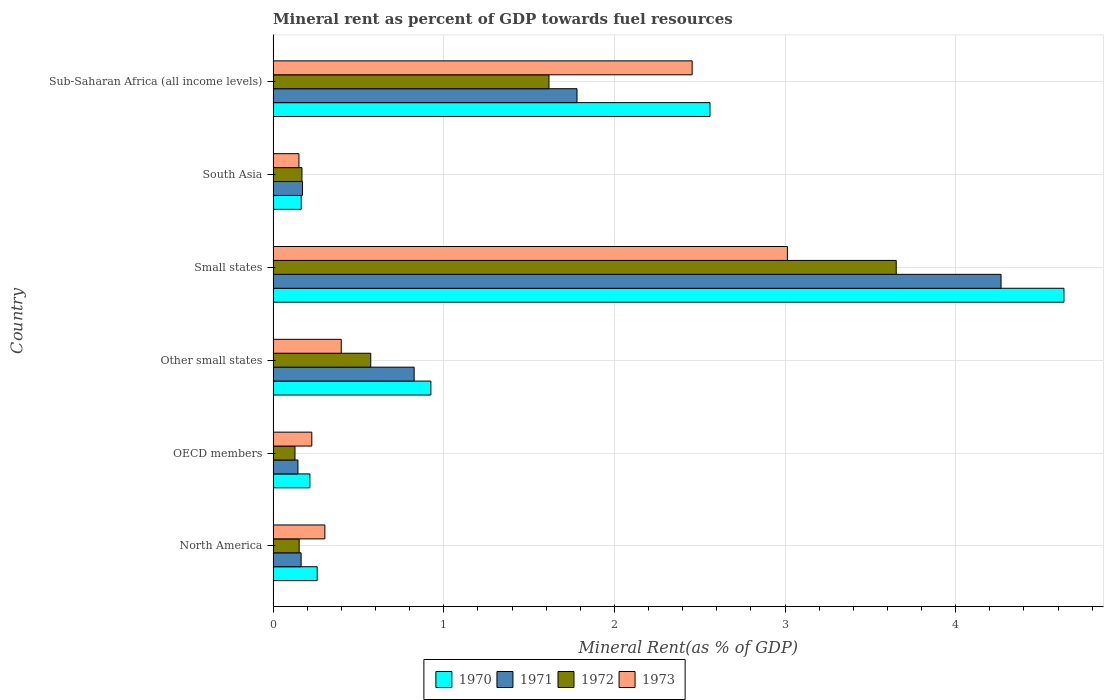Are the number of bars per tick equal to the number of legend labels?
Your answer should be very brief. Yes. How many bars are there on the 1st tick from the bottom?
Offer a very short reply. 4. What is the label of the 6th group of bars from the top?
Your response must be concise. North America. In how many cases, is the number of bars for a given country not equal to the number of legend labels?
Keep it short and to the point. 0. What is the mineral rent in 1970 in OECD members?
Provide a succinct answer. 0.22. Across all countries, what is the maximum mineral rent in 1970?
Ensure brevity in your answer.  4.63. Across all countries, what is the minimum mineral rent in 1973?
Make the answer very short. 0.15. In which country was the mineral rent in 1973 maximum?
Make the answer very short. Small states. In which country was the mineral rent in 1970 minimum?
Ensure brevity in your answer.  South Asia. What is the total mineral rent in 1970 in the graph?
Your answer should be very brief. 8.76. What is the difference between the mineral rent in 1971 in OECD members and that in Small states?
Make the answer very short. -4.12. What is the difference between the mineral rent in 1971 in Sub-Saharan Africa (all income levels) and the mineral rent in 1972 in North America?
Make the answer very short. 1.63. What is the average mineral rent in 1971 per country?
Your response must be concise. 1.23. What is the difference between the mineral rent in 1970 and mineral rent in 1972 in Other small states?
Provide a short and direct response. 0.35. In how many countries, is the mineral rent in 1971 greater than 3.8 %?
Offer a very short reply. 1. What is the ratio of the mineral rent in 1972 in Other small states to that in South Asia?
Keep it short and to the point. 3.38. Is the mineral rent in 1970 in OECD members less than that in South Asia?
Ensure brevity in your answer.  No. Is the difference between the mineral rent in 1970 in Small states and South Asia greater than the difference between the mineral rent in 1972 in Small states and South Asia?
Keep it short and to the point. Yes. What is the difference between the highest and the second highest mineral rent in 1970?
Ensure brevity in your answer.  2.07. What is the difference between the highest and the lowest mineral rent in 1970?
Your answer should be very brief. 4.47. Is the sum of the mineral rent in 1971 in Other small states and Small states greater than the maximum mineral rent in 1973 across all countries?
Ensure brevity in your answer.  Yes. Is it the case that in every country, the sum of the mineral rent in 1970 and mineral rent in 1973 is greater than the sum of mineral rent in 1971 and mineral rent in 1972?
Provide a succinct answer. No. What does the 4th bar from the top in Sub-Saharan Africa (all income levels) represents?
Keep it short and to the point. 1970. Is it the case that in every country, the sum of the mineral rent in 1971 and mineral rent in 1973 is greater than the mineral rent in 1972?
Offer a very short reply. Yes. How many countries are there in the graph?
Your response must be concise. 6. What is the difference between two consecutive major ticks on the X-axis?
Make the answer very short. 1. Are the values on the major ticks of X-axis written in scientific E-notation?
Offer a terse response. No. Does the graph contain any zero values?
Offer a very short reply. No. Does the graph contain grids?
Offer a terse response. Yes. Where does the legend appear in the graph?
Offer a very short reply. Bottom center. What is the title of the graph?
Your answer should be very brief. Mineral rent as percent of GDP towards fuel resources. Does "1996" appear as one of the legend labels in the graph?
Keep it short and to the point. No. What is the label or title of the X-axis?
Your answer should be very brief. Mineral Rent(as % of GDP). What is the Mineral Rent(as % of GDP) in 1970 in North America?
Provide a short and direct response. 0.26. What is the Mineral Rent(as % of GDP) in 1971 in North America?
Offer a terse response. 0.16. What is the Mineral Rent(as % of GDP) in 1972 in North America?
Offer a very short reply. 0.15. What is the Mineral Rent(as % of GDP) of 1973 in North America?
Give a very brief answer. 0.3. What is the Mineral Rent(as % of GDP) of 1970 in OECD members?
Offer a terse response. 0.22. What is the Mineral Rent(as % of GDP) in 1971 in OECD members?
Your answer should be compact. 0.15. What is the Mineral Rent(as % of GDP) in 1972 in OECD members?
Your answer should be compact. 0.13. What is the Mineral Rent(as % of GDP) of 1973 in OECD members?
Ensure brevity in your answer.  0.23. What is the Mineral Rent(as % of GDP) of 1970 in Other small states?
Your answer should be very brief. 0.92. What is the Mineral Rent(as % of GDP) of 1971 in Other small states?
Keep it short and to the point. 0.83. What is the Mineral Rent(as % of GDP) in 1972 in Other small states?
Your answer should be compact. 0.57. What is the Mineral Rent(as % of GDP) of 1973 in Other small states?
Offer a very short reply. 0.4. What is the Mineral Rent(as % of GDP) of 1970 in Small states?
Your response must be concise. 4.63. What is the Mineral Rent(as % of GDP) in 1971 in Small states?
Your response must be concise. 4.27. What is the Mineral Rent(as % of GDP) in 1972 in Small states?
Offer a very short reply. 3.65. What is the Mineral Rent(as % of GDP) of 1973 in Small states?
Make the answer very short. 3.01. What is the Mineral Rent(as % of GDP) in 1970 in South Asia?
Offer a very short reply. 0.16. What is the Mineral Rent(as % of GDP) of 1971 in South Asia?
Give a very brief answer. 0.17. What is the Mineral Rent(as % of GDP) of 1972 in South Asia?
Provide a succinct answer. 0.17. What is the Mineral Rent(as % of GDP) of 1973 in South Asia?
Your response must be concise. 0.15. What is the Mineral Rent(as % of GDP) of 1970 in Sub-Saharan Africa (all income levels)?
Offer a very short reply. 2.56. What is the Mineral Rent(as % of GDP) in 1971 in Sub-Saharan Africa (all income levels)?
Give a very brief answer. 1.78. What is the Mineral Rent(as % of GDP) in 1972 in Sub-Saharan Africa (all income levels)?
Offer a very short reply. 1.62. What is the Mineral Rent(as % of GDP) of 1973 in Sub-Saharan Africa (all income levels)?
Your response must be concise. 2.46. Across all countries, what is the maximum Mineral Rent(as % of GDP) of 1970?
Your answer should be very brief. 4.63. Across all countries, what is the maximum Mineral Rent(as % of GDP) in 1971?
Ensure brevity in your answer.  4.27. Across all countries, what is the maximum Mineral Rent(as % of GDP) of 1972?
Your answer should be compact. 3.65. Across all countries, what is the maximum Mineral Rent(as % of GDP) of 1973?
Provide a short and direct response. 3.01. Across all countries, what is the minimum Mineral Rent(as % of GDP) in 1970?
Provide a succinct answer. 0.16. Across all countries, what is the minimum Mineral Rent(as % of GDP) in 1971?
Provide a short and direct response. 0.15. Across all countries, what is the minimum Mineral Rent(as % of GDP) in 1972?
Keep it short and to the point. 0.13. Across all countries, what is the minimum Mineral Rent(as % of GDP) of 1973?
Your response must be concise. 0.15. What is the total Mineral Rent(as % of GDP) in 1970 in the graph?
Make the answer very short. 8.76. What is the total Mineral Rent(as % of GDP) of 1971 in the graph?
Keep it short and to the point. 7.36. What is the total Mineral Rent(as % of GDP) of 1972 in the graph?
Provide a succinct answer. 6.29. What is the total Mineral Rent(as % of GDP) of 1973 in the graph?
Give a very brief answer. 6.55. What is the difference between the Mineral Rent(as % of GDP) in 1970 in North America and that in OECD members?
Your answer should be compact. 0.04. What is the difference between the Mineral Rent(as % of GDP) in 1971 in North America and that in OECD members?
Your answer should be very brief. 0.02. What is the difference between the Mineral Rent(as % of GDP) in 1972 in North America and that in OECD members?
Offer a very short reply. 0.02. What is the difference between the Mineral Rent(as % of GDP) in 1973 in North America and that in OECD members?
Provide a short and direct response. 0.08. What is the difference between the Mineral Rent(as % of GDP) of 1970 in North America and that in Other small states?
Offer a very short reply. -0.67. What is the difference between the Mineral Rent(as % of GDP) of 1971 in North America and that in Other small states?
Offer a terse response. -0.66. What is the difference between the Mineral Rent(as % of GDP) in 1972 in North America and that in Other small states?
Ensure brevity in your answer.  -0.42. What is the difference between the Mineral Rent(as % of GDP) in 1973 in North America and that in Other small states?
Keep it short and to the point. -0.1. What is the difference between the Mineral Rent(as % of GDP) of 1970 in North America and that in Small states?
Make the answer very short. -4.38. What is the difference between the Mineral Rent(as % of GDP) in 1971 in North America and that in Small states?
Give a very brief answer. -4.1. What is the difference between the Mineral Rent(as % of GDP) of 1972 in North America and that in Small states?
Make the answer very short. -3.5. What is the difference between the Mineral Rent(as % of GDP) in 1973 in North America and that in Small states?
Give a very brief answer. -2.71. What is the difference between the Mineral Rent(as % of GDP) in 1970 in North America and that in South Asia?
Your response must be concise. 0.09. What is the difference between the Mineral Rent(as % of GDP) of 1971 in North America and that in South Asia?
Offer a very short reply. -0.01. What is the difference between the Mineral Rent(as % of GDP) in 1972 in North America and that in South Asia?
Your answer should be compact. -0.02. What is the difference between the Mineral Rent(as % of GDP) of 1973 in North America and that in South Asia?
Your response must be concise. 0.15. What is the difference between the Mineral Rent(as % of GDP) in 1970 in North America and that in Sub-Saharan Africa (all income levels)?
Ensure brevity in your answer.  -2.3. What is the difference between the Mineral Rent(as % of GDP) of 1971 in North America and that in Sub-Saharan Africa (all income levels)?
Your answer should be very brief. -1.62. What is the difference between the Mineral Rent(as % of GDP) of 1972 in North America and that in Sub-Saharan Africa (all income levels)?
Give a very brief answer. -1.46. What is the difference between the Mineral Rent(as % of GDP) of 1973 in North America and that in Sub-Saharan Africa (all income levels)?
Offer a very short reply. -2.15. What is the difference between the Mineral Rent(as % of GDP) in 1970 in OECD members and that in Other small states?
Provide a succinct answer. -0.71. What is the difference between the Mineral Rent(as % of GDP) of 1971 in OECD members and that in Other small states?
Make the answer very short. -0.68. What is the difference between the Mineral Rent(as % of GDP) of 1972 in OECD members and that in Other small states?
Offer a very short reply. -0.44. What is the difference between the Mineral Rent(as % of GDP) in 1973 in OECD members and that in Other small states?
Make the answer very short. -0.17. What is the difference between the Mineral Rent(as % of GDP) in 1970 in OECD members and that in Small states?
Your response must be concise. -4.42. What is the difference between the Mineral Rent(as % of GDP) of 1971 in OECD members and that in Small states?
Your answer should be compact. -4.12. What is the difference between the Mineral Rent(as % of GDP) in 1972 in OECD members and that in Small states?
Give a very brief answer. -3.52. What is the difference between the Mineral Rent(as % of GDP) of 1973 in OECD members and that in Small states?
Your answer should be compact. -2.79. What is the difference between the Mineral Rent(as % of GDP) of 1970 in OECD members and that in South Asia?
Make the answer very short. 0.05. What is the difference between the Mineral Rent(as % of GDP) in 1971 in OECD members and that in South Asia?
Ensure brevity in your answer.  -0.03. What is the difference between the Mineral Rent(as % of GDP) in 1972 in OECD members and that in South Asia?
Your response must be concise. -0.04. What is the difference between the Mineral Rent(as % of GDP) in 1973 in OECD members and that in South Asia?
Provide a short and direct response. 0.08. What is the difference between the Mineral Rent(as % of GDP) of 1970 in OECD members and that in Sub-Saharan Africa (all income levels)?
Provide a short and direct response. -2.34. What is the difference between the Mineral Rent(as % of GDP) in 1971 in OECD members and that in Sub-Saharan Africa (all income levels)?
Your answer should be compact. -1.64. What is the difference between the Mineral Rent(as % of GDP) in 1972 in OECD members and that in Sub-Saharan Africa (all income levels)?
Your answer should be compact. -1.49. What is the difference between the Mineral Rent(as % of GDP) of 1973 in OECD members and that in Sub-Saharan Africa (all income levels)?
Provide a succinct answer. -2.23. What is the difference between the Mineral Rent(as % of GDP) of 1970 in Other small states and that in Small states?
Keep it short and to the point. -3.71. What is the difference between the Mineral Rent(as % of GDP) in 1971 in Other small states and that in Small states?
Provide a short and direct response. -3.44. What is the difference between the Mineral Rent(as % of GDP) in 1972 in Other small states and that in Small states?
Ensure brevity in your answer.  -3.08. What is the difference between the Mineral Rent(as % of GDP) in 1973 in Other small states and that in Small states?
Offer a very short reply. -2.61. What is the difference between the Mineral Rent(as % of GDP) in 1970 in Other small states and that in South Asia?
Your response must be concise. 0.76. What is the difference between the Mineral Rent(as % of GDP) in 1971 in Other small states and that in South Asia?
Ensure brevity in your answer.  0.65. What is the difference between the Mineral Rent(as % of GDP) of 1972 in Other small states and that in South Asia?
Provide a succinct answer. 0.4. What is the difference between the Mineral Rent(as % of GDP) in 1973 in Other small states and that in South Asia?
Provide a succinct answer. 0.25. What is the difference between the Mineral Rent(as % of GDP) of 1970 in Other small states and that in Sub-Saharan Africa (all income levels)?
Offer a very short reply. -1.64. What is the difference between the Mineral Rent(as % of GDP) of 1971 in Other small states and that in Sub-Saharan Africa (all income levels)?
Provide a short and direct response. -0.95. What is the difference between the Mineral Rent(as % of GDP) of 1972 in Other small states and that in Sub-Saharan Africa (all income levels)?
Give a very brief answer. -1.04. What is the difference between the Mineral Rent(as % of GDP) in 1973 in Other small states and that in Sub-Saharan Africa (all income levels)?
Offer a terse response. -2.06. What is the difference between the Mineral Rent(as % of GDP) of 1970 in Small states and that in South Asia?
Offer a terse response. 4.47. What is the difference between the Mineral Rent(as % of GDP) in 1971 in Small states and that in South Asia?
Your answer should be compact. 4.09. What is the difference between the Mineral Rent(as % of GDP) of 1972 in Small states and that in South Asia?
Provide a succinct answer. 3.48. What is the difference between the Mineral Rent(as % of GDP) in 1973 in Small states and that in South Asia?
Ensure brevity in your answer.  2.86. What is the difference between the Mineral Rent(as % of GDP) of 1970 in Small states and that in Sub-Saharan Africa (all income levels)?
Keep it short and to the point. 2.07. What is the difference between the Mineral Rent(as % of GDP) of 1971 in Small states and that in Sub-Saharan Africa (all income levels)?
Offer a terse response. 2.49. What is the difference between the Mineral Rent(as % of GDP) in 1972 in Small states and that in Sub-Saharan Africa (all income levels)?
Ensure brevity in your answer.  2.04. What is the difference between the Mineral Rent(as % of GDP) of 1973 in Small states and that in Sub-Saharan Africa (all income levels)?
Your response must be concise. 0.56. What is the difference between the Mineral Rent(as % of GDP) of 1970 in South Asia and that in Sub-Saharan Africa (all income levels)?
Keep it short and to the point. -2.4. What is the difference between the Mineral Rent(as % of GDP) in 1971 in South Asia and that in Sub-Saharan Africa (all income levels)?
Provide a succinct answer. -1.61. What is the difference between the Mineral Rent(as % of GDP) of 1972 in South Asia and that in Sub-Saharan Africa (all income levels)?
Your answer should be very brief. -1.45. What is the difference between the Mineral Rent(as % of GDP) of 1973 in South Asia and that in Sub-Saharan Africa (all income levels)?
Keep it short and to the point. -2.3. What is the difference between the Mineral Rent(as % of GDP) in 1970 in North America and the Mineral Rent(as % of GDP) in 1971 in OECD members?
Your answer should be very brief. 0.11. What is the difference between the Mineral Rent(as % of GDP) in 1970 in North America and the Mineral Rent(as % of GDP) in 1972 in OECD members?
Ensure brevity in your answer.  0.13. What is the difference between the Mineral Rent(as % of GDP) in 1970 in North America and the Mineral Rent(as % of GDP) in 1973 in OECD members?
Provide a short and direct response. 0.03. What is the difference between the Mineral Rent(as % of GDP) in 1971 in North America and the Mineral Rent(as % of GDP) in 1972 in OECD members?
Your answer should be very brief. 0.04. What is the difference between the Mineral Rent(as % of GDP) in 1971 in North America and the Mineral Rent(as % of GDP) in 1973 in OECD members?
Your answer should be very brief. -0.06. What is the difference between the Mineral Rent(as % of GDP) of 1972 in North America and the Mineral Rent(as % of GDP) of 1973 in OECD members?
Provide a short and direct response. -0.07. What is the difference between the Mineral Rent(as % of GDP) of 1970 in North America and the Mineral Rent(as % of GDP) of 1971 in Other small states?
Offer a very short reply. -0.57. What is the difference between the Mineral Rent(as % of GDP) in 1970 in North America and the Mineral Rent(as % of GDP) in 1972 in Other small states?
Provide a short and direct response. -0.31. What is the difference between the Mineral Rent(as % of GDP) of 1970 in North America and the Mineral Rent(as % of GDP) of 1973 in Other small states?
Your answer should be compact. -0.14. What is the difference between the Mineral Rent(as % of GDP) in 1971 in North America and the Mineral Rent(as % of GDP) in 1972 in Other small states?
Your answer should be compact. -0.41. What is the difference between the Mineral Rent(as % of GDP) of 1971 in North America and the Mineral Rent(as % of GDP) of 1973 in Other small states?
Offer a terse response. -0.24. What is the difference between the Mineral Rent(as % of GDP) of 1972 in North America and the Mineral Rent(as % of GDP) of 1973 in Other small states?
Your answer should be compact. -0.25. What is the difference between the Mineral Rent(as % of GDP) in 1970 in North America and the Mineral Rent(as % of GDP) in 1971 in Small states?
Provide a short and direct response. -4.01. What is the difference between the Mineral Rent(as % of GDP) of 1970 in North America and the Mineral Rent(as % of GDP) of 1972 in Small states?
Make the answer very short. -3.39. What is the difference between the Mineral Rent(as % of GDP) of 1970 in North America and the Mineral Rent(as % of GDP) of 1973 in Small states?
Your response must be concise. -2.76. What is the difference between the Mineral Rent(as % of GDP) in 1971 in North America and the Mineral Rent(as % of GDP) in 1972 in Small states?
Your answer should be compact. -3.49. What is the difference between the Mineral Rent(as % of GDP) in 1971 in North America and the Mineral Rent(as % of GDP) in 1973 in Small states?
Your response must be concise. -2.85. What is the difference between the Mineral Rent(as % of GDP) in 1972 in North America and the Mineral Rent(as % of GDP) in 1973 in Small states?
Offer a very short reply. -2.86. What is the difference between the Mineral Rent(as % of GDP) in 1970 in North America and the Mineral Rent(as % of GDP) in 1971 in South Asia?
Provide a succinct answer. 0.09. What is the difference between the Mineral Rent(as % of GDP) in 1970 in North America and the Mineral Rent(as % of GDP) in 1972 in South Asia?
Give a very brief answer. 0.09. What is the difference between the Mineral Rent(as % of GDP) in 1970 in North America and the Mineral Rent(as % of GDP) in 1973 in South Asia?
Give a very brief answer. 0.11. What is the difference between the Mineral Rent(as % of GDP) in 1971 in North America and the Mineral Rent(as % of GDP) in 1972 in South Asia?
Ensure brevity in your answer.  -0.01. What is the difference between the Mineral Rent(as % of GDP) of 1971 in North America and the Mineral Rent(as % of GDP) of 1973 in South Asia?
Give a very brief answer. 0.01. What is the difference between the Mineral Rent(as % of GDP) of 1972 in North America and the Mineral Rent(as % of GDP) of 1973 in South Asia?
Offer a very short reply. 0. What is the difference between the Mineral Rent(as % of GDP) of 1970 in North America and the Mineral Rent(as % of GDP) of 1971 in Sub-Saharan Africa (all income levels)?
Give a very brief answer. -1.52. What is the difference between the Mineral Rent(as % of GDP) of 1970 in North America and the Mineral Rent(as % of GDP) of 1972 in Sub-Saharan Africa (all income levels)?
Provide a short and direct response. -1.36. What is the difference between the Mineral Rent(as % of GDP) in 1970 in North America and the Mineral Rent(as % of GDP) in 1973 in Sub-Saharan Africa (all income levels)?
Your answer should be compact. -2.2. What is the difference between the Mineral Rent(as % of GDP) of 1971 in North America and the Mineral Rent(as % of GDP) of 1972 in Sub-Saharan Africa (all income levels)?
Your answer should be compact. -1.45. What is the difference between the Mineral Rent(as % of GDP) in 1971 in North America and the Mineral Rent(as % of GDP) in 1973 in Sub-Saharan Africa (all income levels)?
Your answer should be very brief. -2.29. What is the difference between the Mineral Rent(as % of GDP) in 1972 in North America and the Mineral Rent(as % of GDP) in 1973 in Sub-Saharan Africa (all income levels)?
Your answer should be compact. -2.3. What is the difference between the Mineral Rent(as % of GDP) in 1970 in OECD members and the Mineral Rent(as % of GDP) in 1971 in Other small states?
Offer a terse response. -0.61. What is the difference between the Mineral Rent(as % of GDP) in 1970 in OECD members and the Mineral Rent(as % of GDP) in 1972 in Other small states?
Your answer should be very brief. -0.36. What is the difference between the Mineral Rent(as % of GDP) in 1970 in OECD members and the Mineral Rent(as % of GDP) in 1973 in Other small states?
Keep it short and to the point. -0.18. What is the difference between the Mineral Rent(as % of GDP) of 1971 in OECD members and the Mineral Rent(as % of GDP) of 1972 in Other small states?
Your response must be concise. -0.43. What is the difference between the Mineral Rent(as % of GDP) of 1971 in OECD members and the Mineral Rent(as % of GDP) of 1973 in Other small states?
Offer a terse response. -0.25. What is the difference between the Mineral Rent(as % of GDP) of 1972 in OECD members and the Mineral Rent(as % of GDP) of 1973 in Other small states?
Your answer should be very brief. -0.27. What is the difference between the Mineral Rent(as % of GDP) in 1970 in OECD members and the Mineral Rent(as % of GDP) in 1971 in Small states?
Keep it short and to the point. -4.05. What is the difference between the Mineral Rent(as % of GDP) in 1970 in OECD members and the Mineral Rent(as % of GDP) in 1972 in Small states?
Provide a succinct answer. -3.44. What is the difference between the Mineral Rent(as % of GDP) in 1970 in OECD members and the Mineral Rent(as % of GDP) in 1973 in Small states?
Provide a short and direct response. -2.8. What is the difference between the Mineral Rent(as % of GDP) in 1971 in OECD members and the Mineral Rent(as % of GDP) in 1972 in Small states?
Provide a short and direct response. -3.51. What is the difference between the Mineral Rent(as % of GDP) of 1971 in OECD members and the Mineral Rent(as % of GDP) of 1973 in Small states?
Give a very brief answer. -2.87. What is the difference between the Mineral Rent(as % of GDP) in 1972 in OECD members and the Mineral Rent(as % of GDP) in 1973 in Small states?
Give a very brief answer. -2.89. What is the difference between the Mineral Rent(as % of GDP) of 1970 in OECD members and the Mineral Rent(as % of GDP) of 1971 in South Asia?
Provide a succinct answer. 0.04. What is the difference between the Mineral Rent(as % of GDP) in 1970 in OECD members and the Mineral Rent(as % of GDP) in 1972 in South Asia?
Offer a very short reply. 0.05. What is the difference between the Mineral Rent(as % of GDP) in 1970 in OECD members and the Mineral Rent(as % of GDP) in 1973 in South Asia?
Give a very brief answer. 0.06. What is the difference between the Mineral Rent(as % of GDP) in 1971 in OECD members and the Mineral Rent(as % of GDP) in 1972 in South Asia?
Offer a terse response. -0.02. What is the difference between the Mineral Rent(as % of GDP) in 1971 in OECD members and the Mineral Rent(as % of GDP) in 1973 in South Asia?
Make the answer very short. -0.01. What is the difference between the Mineral Rent(as % of GDP) of 1972 in OECD members and the Mineral Rent(as % of GDP) of 1973 in South Asia?
Your answer should be very brief. -0.02. What is the difference between the Mineral Rent(as % of GDP) of 1970 in OECD members and the Mineral Rent(as % of GDP) of 1971 in Sub-Saharan Africa (all income levels)?
Ensure brevity in your answer.  -1.57. What is the difference between the Mineral Rent(as % of GDP) in 1970 in OECD members and the Mineral Rent(as % of GDP) in 1972 in Sub-Saharan Africa (all income levels)?
Your answer should be very brief. -1.4. What is the difference between the Mineral Rent(as % of GDP) in 1970 in OECD members and the Mineral Rent(as % of GDP) in 1973 in Sub-Saharan Africa (all income levels)?
Your response must be concise. -2.24. What is the difference between the Mineral Rent(as % of GDP) in 1971 in OECD members and the Mineral Rent(as % of GDP) in 1972 in Sub-Saharan Africa (all income levels)?
Your response must be concise. -1.47. What is the difference between the Mineral Rent(as % of GDP) in 1971 in OECD members and the Mineral Rent(as % of GDP) in 1973 in Sub-Saharan Africa (all income levels)?
Offer a terse response. -2.31. What is the difference between the Mineral Rent(as % of GDP) of 1972 in OECD members and the Mineral Rent(as % of GDP) of 1973 in Sub-Saharan Africa (all income levels)?
Offer a very short reply. -2.33. What is the difference between the Mineral Rent(as % of GDP) in 1970 in Other small states and the Mineral Rent(as % of GDP) in 1971 in Small states?
Offer a terse response. -3.34. What is the difference between the Mineral Rent(as % of GDP) of 1970 in Other small states and the Mineral Rent(as % of GDP) of 1972 in Small states?
Offer a very short reply. -2.73. What is the difference between the Mineral Rent(as % of GDP) of 1970 in Other small states and the Mineral Rent(as % of GDP) of 1973 in Small states?
Provide a short and direct response. -2.09. What is the difference between the Mineral Rent(as % of GDP) in 1971 in Other small states and the Mineral Rent(as % of GDP) in 1972 in Small states?
Offer a very short reply. -2.83. What is the difference between the Mineral Rent(as % of GDP) of 1971 in Other small states and the Mineral Rent(as % of GDP) of 1973 in Small states?
Offer a very short reply. -2.19. What is the difference between the Mineral Rent(as % of GDP) of 1972 in Other small states and the Mineral Rent(as % of GDP) of 1973 in Small states?
Your answer should be compact. -2.44. What is the difference between the Mineral Rent(as % of GDP) of 1970 in Other small states and the Mineral Rent(as % of GDP) of 1971 in South Asia?
Your response must be concise. 0.75. What is the difference between the Mineral Rent(as % of GDP) in 1970 in Other small states and the Mineral Rent(as % of GDP) in 1972 in South Asia?
Keep it short and to the point. 0.76. What is the difference between the Mineral Rent(as % of GDP) of 1970 in Other small states and the Mineral Rent(as % of GDP) of 1973 in South Asia?
Keep it short and to the point. 0.77. What is the difference between the Mineral Rent(as % of GDP) in 1971 in Other small states and the Mineral Rent(as % of GDP) in 1972 in South Asia?
Your answer should be compact. 0.66. What is the difference between the Mineral Rent(as % of GDP) of 1971 in Other small states and the Mineral Rent(as % of GDP) of 1973 in South Asia?
Make the answer very short. 0.68. What is the difference between the Mineral Rent(as % of GDP) of 1972 in Other small states and the Mineral Rent(as % of GDP) of 1973 in South Asia?
Keep it short and to the point. 0.42. What is the difference between the Mineral Rent(as % of GDP) of 1970 in Other small states and the Mineral Rent(as % of GDP) of 1971 in Sub-Saharan Africa (all income levels)?
Keep it short and to the point. -0.86. What is the difference between the Mineral Rent(as % of GDP) in 1970 in Other small states and the Mineral Rent(as % of GDP) in 1972 in Sub-Saharan Africa (all income levels)?
Provide a succinct answer. -0.69. What is the difference between the Mineral Rent(as % of GDP) of 1970 in Other small states and the Mineral Rent(as % of GDP) of 1973 in Sub-Saharan Africa (all income levels)?
Keep it short and to the point. -1.53. What is the difference between the Mineral Rent(as % of GDP) in 1971 in Other small states and the Mineral Rent(as % of GDP) in 1972 in Sub-Saharan Africa (all income levels)?
Your answer should be very brief. -0.79. What is the difference between the Mineral Rent(as % of GDP) in 1971 in Other small states and the Mineral Rent(as % of GDP) in 1973 in Sub-Saharan Africa (all income levels)?
Keep it short and to the point. -1.63. What is the difference between the Mineral Rent(as % of GDP) in 1972 in Other small states and the Mineral Rent(as % of GDP) in 1973 in Sub-Saharan Africa (all income levels)?
Provide a short and direct response. -1.88. What is the difference between the Mineral Rent(as % of GDP) of 1970 in Small states and the Mineral Rent(as % of GDP) of 1971 in South Asia?
Offer a terse response. 4.46. What is the difference between the Mineral Rent(as % of GDP) in 1970 in Small states and the Mineral Rent(as % of GDP) in 1972 in South Asia?
Make the answer very short. 4.47. What is the difference between the Mineral Rent(as % of GDP) of 1970 in Small states and the Mineral Rent(as % of GDP) of 1973 in South Asia?
Offer a terse response. 4.48. What is the difference between the Mineral Rent(as % of GDP) of 1971 in Small states and the Mineral Rent(as % of GDP) of 1972 in South Asia?
Keep it short and to the point. 4.1. What is the difference between the Mineral Rent(as % of GDP) of 1971 in Small states and the Mineral Rent(as % of GDP) of 1973 in South Asia?
Your answer should be very brief. 4.11. What is the difference between the Mineral Rent(as % of GDP) in 1972 in Small states and the Mineral Rent(as % of GDP) in 1973 in South Asia?
Your answer should be very brief. 3.5. What is the difference between the Mineral Rent(as % of GDP) in 1970 in Small states and the Mineral Rent(as % of GDP) in 1971 in Sub-Saharan Africa (all income levels)?
Keep it short and to the point. 2.85. What is the difference between the Mineral Rent(as % of GDP) of 1970 in Small states and the Mineral Rent(as % of GDP) of 1972 in Sub-Saharan Africa (all income levels)?
Provide a succinct answer. 3.02. What is the difference between the Mineral Rent(as % of GDP) of 1970 in Small states and the Mineral Rent(as % of GDP) of 1973 in Sub-Saharan Africa (all income levels)?
Provide a succinct answer. 2.18. What is the difference between the Mineral Rent(as % of GDP) of 1971 in Small states and the Mineral Rent(as % of GDP) of 1972 in Sub-Saharan Africa (all income levels)?
Offer a very short reply. 2.65. What is the difference between the Mineral Rent(as % of GDP) of 1971 in Small states and the Mineral Rent(as % of GDP) of 1973 in Sub-Saharan Africa (all income levels)?
Give a very brief answer. 1.81. What is the difference between the Mineral Rent(as % of GDP) in 1972 in Small states and the Mineral Rent(as % of GDP) in 1973 in Sub-Saharan Africa (all income levels)?
Your response must be concise. 1.2. What is the difference between the Mineral Rent(as % of GDP) of 1970 in South Asia and the Mineral Rent(as % of GDP) of 1971 in Sub-Saharan Africa (all income levels)?
Your answer should be compact. -1.62. What is the difference between the Mineral Rent(as % of GDP) of 1970 in South Asia and the Mineral Rent(as % of GDP) of 1972 in Sub-Saharan Africa (all income levels)?
Offer a terse response. -1.45. What is the difference between the Mineral Rent(as % of GDP) in 1970 in South Asia and the Mineral Rent(as % of GDP) in 1973 in Sub-Saharan Africa (all income levels)?
Give a very brief answer. -2.29. What is the difference between the Mineral Rent(as % of GDP) of 1971 in South Asia and the Mineral Rent(as % of GDP) of 1972 in Sub-Saharan Africa (all income levels)?
Make the answer very short. -1.44. What is the difference between the Mineral Rent(as % of GDP) in 1971 in South Asia and the Mineral Rent(as % of GDP) in 1973 in Sub-Saharan Africa (all income levels)?
Your answer should be compact. -2.28. What is the difference between the Mineral Rent(as % of GDP) in 1972 in South Asia and the Mineral Rent(as % of GDP) in 1973 in Sub-Saharan Africa (all income levels)?
Your answer should be compact. -2.29. What is the average Mineral Rent(as % of GDP) of 1970 per country?
Offer a very short reply. 1.46. What is the average Mineral Rent(as % of GDP) in 1971 per country?
Your answer should be compact. 1.23. What is the average Mineral Rent(as % of GDP) of 1972 per country?
Your answer should be very brief. 1.05. What is the average Mineral Rent(as % of GDP) of 1973 per country?
Ensure brevity in your answer.  1.09. What is the difference between the Mineral Rent(as % of GDP) in 1970 and Mineral Rent(as % of GDP) in 1971 in North America?
Your response must be concise. 0.09. What is the difference between the Mineral Rent(as % of GDP) in 1970 and Mineral Rent(as % of GDP) in 1972 in North America?
Your answer should be compact. 0.11. What is the difference between the Mineral Rent(as % of GDP) in 1970 and Mineral Rent(as % of GDP) in 1973 in North America?
Your answer should be compact. -0.04. What is the difference between the Mineral Rent(as % of GDP) in 1971 and Mineral Rent(as % of GDP) in 1972 in North America?
Your answer should be compact. 0.01. What is the difference between the Mineral Rent(as % of GDP) of 1971 and Mineral Rent(as % of GDP) of 1973 in North America?
Your response must be concise. -0.14. What is the difference between the Mineral Rent(as % of GDP) of 1972 and Mineral Rent(as % of GDP) of 1973 in North America?
Offer a terse response. -0.15. What is the difference between the Mineral Rent(as % of GDP) of 1970 and Mineral Rent(as % of GDP) of 1971 in OECD members?
Make the answer very short. 0.07. What is the difference between the Mineral Rent(as % of GDP) in 1970 and Mineral Rent(as % of GDP) in 1972 in OECD members?
Offer a terse response. 0.09. What is the difference between the Mineral Rent(as % of GDP) in 1970 and Mineral Rent(as % of GDP) in 1973 in OECD members?
Make the answer very short. -0.01. What is the difference between the Mineral Rent(as % of GDP) of 1971 and Mineral Rent(as % of GDP) of 1972 in OECD members?
Give a very brief answer. 0.02. What is the difference between the Mineral Rent(as % of GDP) in 1971 and Mineral Rent(as % of GDP) in 1973 in OECD members?
Offer a terse response. -0.08. What is the difference between the Mineral Rent(as % of GDP) in 1972 and Mineral Rent(as % of GDP) in 1973 in OECD members?
Ensure brevity in your answer.  -0.1. What is the difference between the Mineral Rent(as % of GDP) of 1970 and Mineral Rent(as % of GDP) of 1971 in Other small states?
Ensure brevity in your answer.  0.1. What is the difference between the Mineral Rent(as % of GDP) of 1970 and Mineral Rent(as % of GDP) of 1972 in Other small states?
Keep it short and to the point. 0.35. What is the difference between the Mineral Rent(as % of GDP) in 1970 and Mineral Rent(as % of GDP) in 1973 in Other small states?
Make the answer very short. 0.53. What is the difference between the Mineral Rent(as % of GDP) of 1971 and Mineral Rent(as % of GDP) of 1972 in Other small states?
Offer a very short reply. 0.25. What is the difference between the Mineral Rent(as % of GDP) of 1971 and Mineral Rent(as % of GDP) of 1973 in Other small states?
Provide a short and direct response. 0.43. What is the difference between the Mineral Rent(as % of GDP) of 1972 and Mineral Rent(as % of GDP) of 1973 in Other small states?
Your response must be concise. 0.17. What is the difference between the Mineral Rent(as % of GDP) of 1970 and Mineral Rent(as % of GDP) of 1971 in Small states?
Your answer should be very brief. 0.37. What is the difference between the Mineral Rent(as % of GDP) of 1970 and Mineral Rent(as % of GDP) of 1972 in Small states?
Your response must be concise. 0.98. What is the difference between the Mineral Rent(as % of GDP) of 1970 and Mineral Rent(as % of GDP) of 1973 in Small states?
Offer a terse response. 1.62. What is the difference between the Mineral Rent(as % of GDP) in 1971 and Mineral Rent(as % of GDP) in 1972 in Small states?
Provide a short and direct response. 0.61. What is the difference between the Mineral Rent(as % of GDP) in 1971 and Mineral Rent(as % of GDP) in 1973 in Small states?
Give a very brief answer. 1.25. What is the difference between the Mineral Rent(as % of GDP) in 1972 and Mineral Rent(as % of GDP) in 1973 in Small states?
Provide a short and direct response. 0.64. What is the difference between the Mineral Rent(as % of GDP) in 1970 and Mineral Rent(as % of GDP) in 1971 in South Asia?
Give a very brief answer. -0.01. What is the difference between the Mineral Rent(as % of GDP) in 1970 and Mineral Rent(as % of GDP) in 1972 in South Asia?
Your response must be concise. -0. What is the difference between the Mineral Rent(as % of GDP) of 1970 and Mineral Rent(as % of GDP) of 1973 in South Asia?
Keep it short and to the point. 0.01. What is the difference between the Mineral Rent(as % of GDP) of 1971 and Mineral Rent(as % of GDP) of 1972 in South Asia?
Give a very brief answer. 0. What is the difference between the Mineral Rent(as % of GDP) in 1971 and Mineral Rent(as % of GDP) in 1973 in South Asia?
Your answer should be very brief. 0.02. What is the difference between the Mineral Rent(as % of GDP) in 1972 and Mineral Rent(as % of GDP) in 1973 in South Asia?
Provide a short and direct response. 0.02. What is the difference between the Mineral Rent(as % of GDP) in 1970 and Mineral Rent(as % of GDP) in 1971 in Sub-Saharan Africa (all income levels)?
Ensure brevity in your answer.  0.78. What is the difference between the Mineral Rent(as % of GDP) of 1970 and Mineral Rent(as % of GDP) of 1972 in Sub-Saharan Africa (all income levels)?
Give a very brief answer. 0.94. What is the difference between the Mineral Rent(as % of GDP) of 1970 and Mineral Rent(as % of GDP) of 1973 in Sub-Saharan Africa (all income levels)?
Make the answer very short. 0.1. What is the difference between the Mineral Rent(as % of GDP) in 1971 and Mineral Rent(as % of GDP) in 1972 in Sub-Saharan Africa (all income levels)?
Give a very brief answer. 0.16. What is the difference between the Mineral Rent(as % of GDP) in 1971 and Mineral Rent(as % of GDP) in 1973 in Sub-Saharan Africa (all income levels)?
Offer a terse response. -0.67. What is the difference between the Mineral Rent(as % of GDP) in 1972 and Mineral Rent(as % of GDP) in 1973 in Sub-Saharan Africa (all income levels)?
Offer a very short reply. -0.84. What is the ratio of the Mineral Rent(as % of GDP) in 1970 in North America to that in OECD members?
Provide a succinct answer. 1.2. What is the ratio of the Mineral Rent(as % of GDP) of 1971 in North America to that in OECD members?
Keep it short and to the point. 1.13. What is the ratio of the Mineral Rent(as % of GDP) of 1972 in North America to that in OECD members?
Provide a succinct answer. 1.19. What is the ratio of the Mineral Rent(as % of GDP) of 1973 in North America to that in OECD members?
Offer a very short reply. 1.34. What is the ratio of the Mineral Rent(as % of GDP) in 1970 in North America to that in Other small states?
Your answer should be compact. 0.28. What is the ratio of the Mineral Rent(as % of GDP) in 1971 in North America to that in Other small states?
Your response must be concise. 0.2. What is the ratio of the Mineral Rent(as % of GDP) of 1972 in North America to that in Other small states?
Keep it short and to the point. 0.27. What is the ratio of the Mineral Rent(as % of GDP) of 1973 in North America to that in Other small states?
Keep it short and to the point. 0.76. What is the ratio of the Mineral Rent(as % of GDP) of 1970 in North America to that in Small states?
Make the answer very short. 0.06. What is the ratio of the Mineral Rent(as % of GDP) of 1971 in North America to that in Small states?
Give a very brief answer. 0.04. What is the ratio of the Mineral Rent(as % of GDP) in 1972 in North America to that in Small states?
Give a very brief answer. 0.04. What is the ratio of the Mineral Rent(as % of GDP) in 1973 in North America to that in Small states?
Offer a terse response. 0.1. What is the ratio of the Mineral Rent(as % of GDP) in 1970 in North America to that in South Asia?
Your answer should be very brief. 1.57. What is the ratio of the Mineral Rent(as % of GDP) in 1971 in North America to that in South Asia?
Offer a terse response. 0.95. What is the ratio of the Mineral Rent(as % of GDP) in 1972 in North America to that in South Asia?
Provide a short and direct response. 0.9. What is the ratio of the Mineral Rent(as % of GDP) in 1973 in North America to that in South Asia?
Give a very brief answer. 2.01. What is the ratio of the Mineral Rent(as % of GDP) of 1970 in North America to that in Sub-Saharan Africa (all income levels)?
Offer a terse response. 0.1. What is the ratio of the Mineral Rent(as % of GDP) of 1971 in North America to that in Sub-Saharan Africa (all income levels)?
Your response must be concise. 0.09. What is the ratio of the Mineral Rent(as % of GDP) of 1972 in North America to that in Sub-Saharan Africa (all income levels)?
Make the answer very short. 0.09. What is the ratio of the Mineral Rent(as % of GDP) of 1973 in North America to that in Sub-Saharan Africa (all income levels)?
Your answer should be very brief. 0.12. What is the ratio of the Mineral Rent(as % of GDP) of 1970 in OECD members to that in Other small states?
Give a very brief answer. 0.23. What is the ratio of the Mineral Rent(as % of GDP) of 1971 in OECD members to that in Other small states?
Provide a short and direct response. 0.18. What is the ratio of the Mineral Rent(as % of GDP) of 1972 in OECD members to that in Other small states?
Keep it short and to the point. 0.22. What is the ratio of the Mineral Rent(as % of GDP) of 1973 in OECD members to that in Other small states?
Give a very brief answer. 0.57. What is the ratio of the Mineral Rent(as % of GDP) of 1970 in OECD members to that in Small states?
Your answer should be compact. 0.05. What is the ratio of the Mineral Rent(as % of GDP) of 1971 in OECD members to that in Small states?
Provide a short and direct response. 0.03. What is the ratio of the Mineral Rent(as % of GDP) of 1972 in OECD members to that in Small states?
Ensure brevity in your answer.  0.04. What is the ratio of the Mineral Rent(as % of GDP) in 1973 in OECD members to that in Small states?
Provide a succinct answer. 0.08. What is the ratio of the Mineral Rent(as % of GDP) of 1970 in OECD members to that in South Asia?
Your answer should be very brief. 1.31. What is the ratio of the Mineral Rent(as % of GDP) of 1971 in OECD members to that in South Asia?
Offer a very short reply. 0.84. What is the ratio of the Mineral Rent(as % of GDP) in 1972 in OECD members to that in South Asia?
Make the answer very short. 0.76. What is the ratio of the Mineral Rent(as % of GDP) of 1973 in OECD members to that in South Asia?
Your answer should be very brief. 1.5. What is the ratio of the Mineral Rent(as % of GDP) in 1970 in OECD members to that in Sub-Saharan Africa (all income levels)?
Your response must be concise. 0.08. What is the ratio of the Mineral Rent(as % of GDP) in 1971 in OECD members to that in Sub-Saharan Africa (all income levels)?
Ensure brevity in your answer.  0.08. What is the ratio of the Mineral Rent(as % of GDP) in 1972 in OECD members to that in Sub-Saharan Africa (all income levels)?
Your response must be concise. 0.08. What is the ratio of the Mineral Rent(as % of GDP) in 1973 in OECD members to that in Sub-Saharan Africa (all income levels)?
Give a very brief answer. 0.09. What is the ratio of the Mineral Rent(as % of GDP) in 1970 in Other small states to that in Small states?
Your answer should be very brief. 0.2. What is the ratio of the Mineral Rent(as % of GDP) of 1971 in Other small states to that in Small states?
Offer a terse response. 0.19. What is the ratio of the Mineral Rent(as % of GDP) of 1972 in Other small states to that in Small states?
Your answer should be very brief. 0.16. What is the ratio of the Mineral Rent(as % of GDP) of 1973 in Other small states to that in Small states?
Give a very brief answer. 0.13. What is the ratio of the Mineral Rent(as % of GDP) of 1970 in Other small states to that in South Asia?
Give a very brief answer. 5.61. What is the ratio of the Mineral Rent(as % of GDP) of 1971 in Other small states to that in South Asia?
Keep it short and to the point. 4.8. What is the ratio of the Mineral Rent(as % of GDP) of 1972 in Other small states to that in South Asia?
Your response must be concise. 3.38. What is the ratio of the Mineral Rent(as % of GDP) in 1973 in Other small states to that in South Asia?
Your answer should be compact. 2.64. What is the ratio of the Mineral Rent(as % of GDP) of 1970 in Other small states to that in Sub-Saharan Africa (all income levels)?
Provide a short and direct response. 0.36. What is the ratio of the Mineral Rent(as % of GDP) of 1971 in Other small states to that in Sub-Saharan Africa (all income levels)?
Provide a succinct answer. 0.46. What is the ratio of the Mineral Rent(as % of GDP) of 1972 in Other small states to that in Sub-Saharan Africa (all income levels)?
Offer a very short reply. 0.35. What is the ratio of the Mineral Rent(as % of GDP) in 1973 in Other small states to that in Sub-Saharan Africa (all income levels)?
Your answer should be compact. 0.16. What is the ratio of the Mineral Rent(as % of GDP) of 1970 in Small states to that in South Asia?
Your answer should be compact. 28.13. What is the ratio of the Mineral Rent(as % of GDP) of 1971 in Small states to that in South Asia?
Offer a terse response. 24.77. What is the ratio of the Mineral Rent(as % of GDP) in 1972 in Small states to that in South Asia?
Provide a succinct answer. 21.6. What is the ratio of the Mineral Rent(as % of GDP) in 1973 in Small states to that in South Asia?
Provide a succinct answer. 19.93. What is the ratio of the Mineral Rent(as % of GDP) of 1970 in Small states to that in Sub-Saharan Africa (all income levels)?
Provide a succinct answer. 1.81. What is the ratio of the Mineral Rent(as % of GDP) in 1971 in Small states to that in Sub-Saharan Africa (all income levels)?
Provide a succinct answer. 2.4. What is the ratio of the Mineral Rent(as % of GDP) of 1972 in Small states to that in Sub-Saharan Africa (all income levels)?
Provide a succinct answer. 2.26. What is the ratio of the Mineral Rent(as % of GDP) of 1973 in Small states to that in Sub-Saharan Africa (all income levels)?
Provide a short and direct response. 1.23. What is the ratio of the Mineral Rent(as % of GDP) of 1970 in South Asia to that in Sub-Saharan Africa (all income levels)?
Your answer should be compact. 0.06. What is the ratio of the Mineral Rent(as % of GDP) of 1971 in South Asia to that in Sub-Saharan Africa (all income levels)?
Provide a short and direct response. 0.1. What is the ratio of the Mineral Rent(as % of GDP) in 1972 in South Asia to that in Sub-Saharan Africa (all income levels)?
Your response must be concise. 0.1. What is the ratio of the Mineral Rent(as % of GDP) of 1973 in South Asia to that in Sub-Saharan Africa (all income levels)?
Give a very brief answer. 0.06. What is the difference between the highest and the second highest Mineral Rent(as % of GDP) of 1970?
Provide a succinct answer. 2.07. What is the difference between the highest and the second highest Mineral Rent(as % of GDP) in 1971?
Offer a very short reply. 2.49. What is the difference between the highest and the second highest Mineral Rent(as % of GDP) in 1972?
Provide a short and direct response. 2.04. What is the difference between the highest and the second highest Mineral Rent(as % of GDP) in 1973?
Keep it short and to the point. 0.56. What is the difference between the highest and the lowest Mineral Rent(as % of GDP) of 1970?
Provide a succinct answer. 4.47. What is the difference between the highest and the lowest Mineral Rent(as % of GDP) in 1971?
Keep it short and to the point. 4.12. What is the difference between the highest and the lowest Mineral Rent(as % of GDP) of 1972?
Provide a succinct answer. 3.52. What is the difference between the highest and the lowest Mineral Rent(as % of GDP) in 1973?
Make the answer very short. 2.86. 